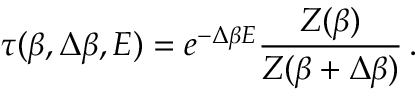<formula> <loc_0><loc_0><loc_500><loc_500>\tau ( \beta , \Delta \beta , E ) = e ^ { - \Delta \beta E } \frac { Z ( \beta ) } { Z ( \beta + \Delta \beta ) } \, .</formula> 